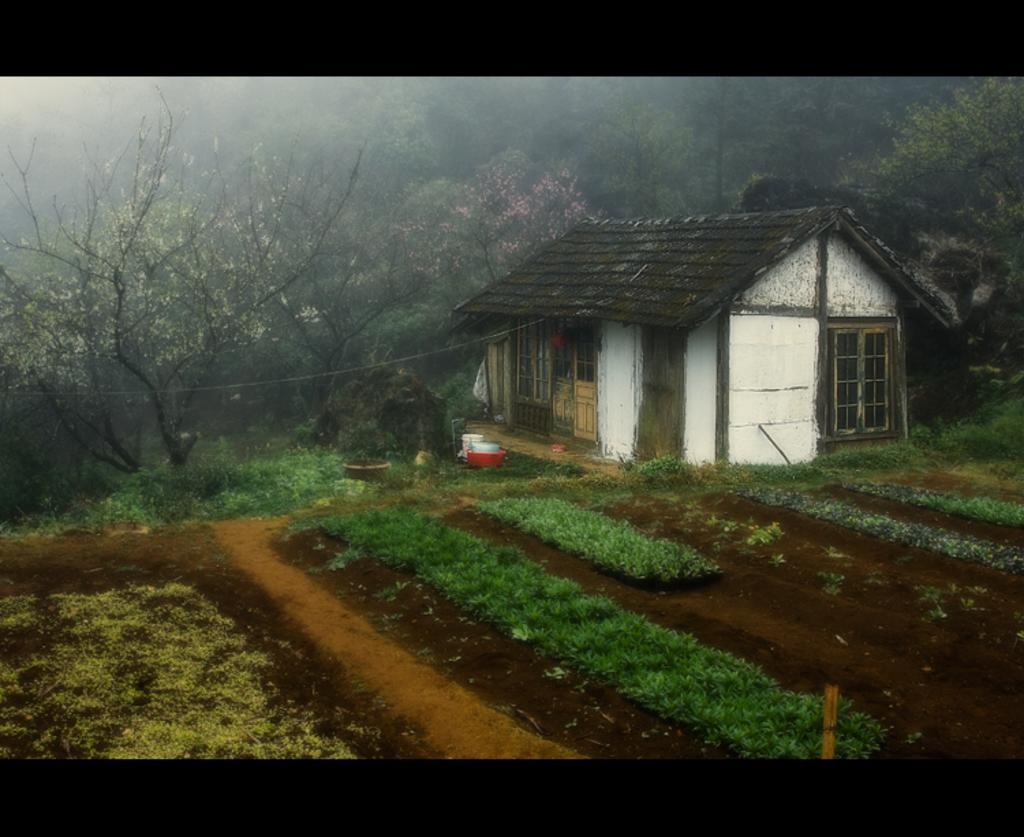Please provide a concise description of this image. This picture is clicked outside. In the foreground we can see the grass and then some plants. On the right there is a house with a black roof top and we can see the door and window of the house and there are some objects placed on the ground. In the background we can see the trees. 